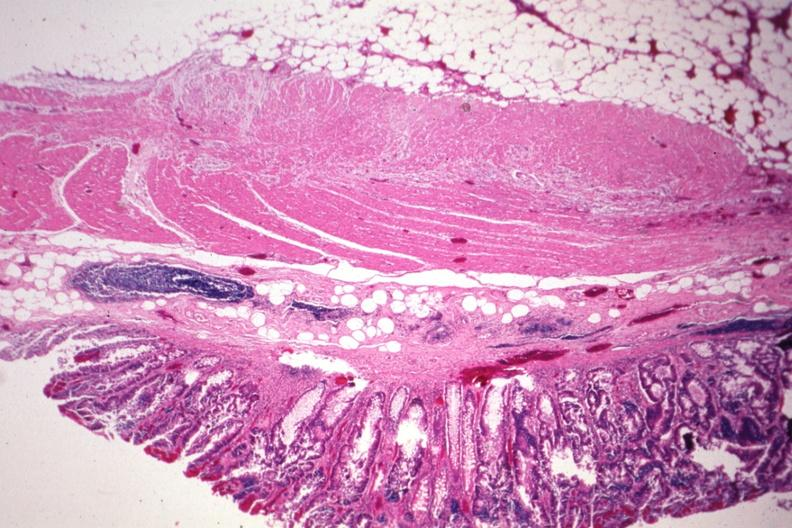what is present?
Answer the question using a single word or phrase. Carcinoma superficial spreading 